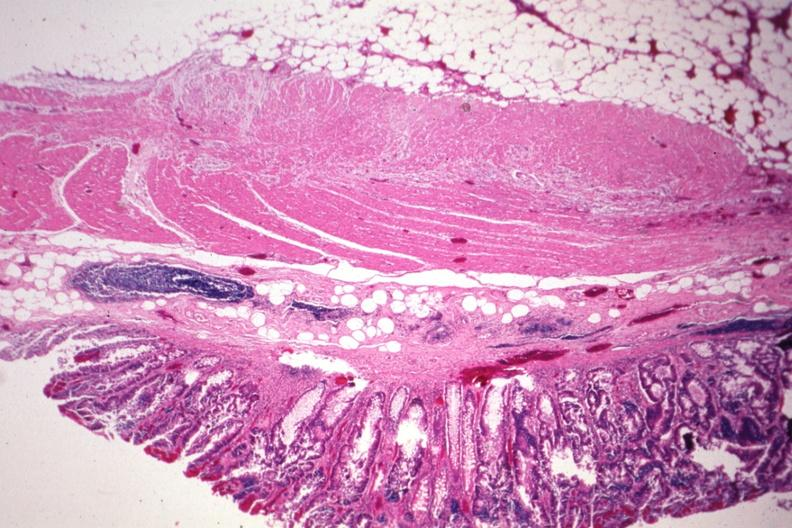what is present?
Answer the question using a single word or phrase. Carcinoma superficial spreading 